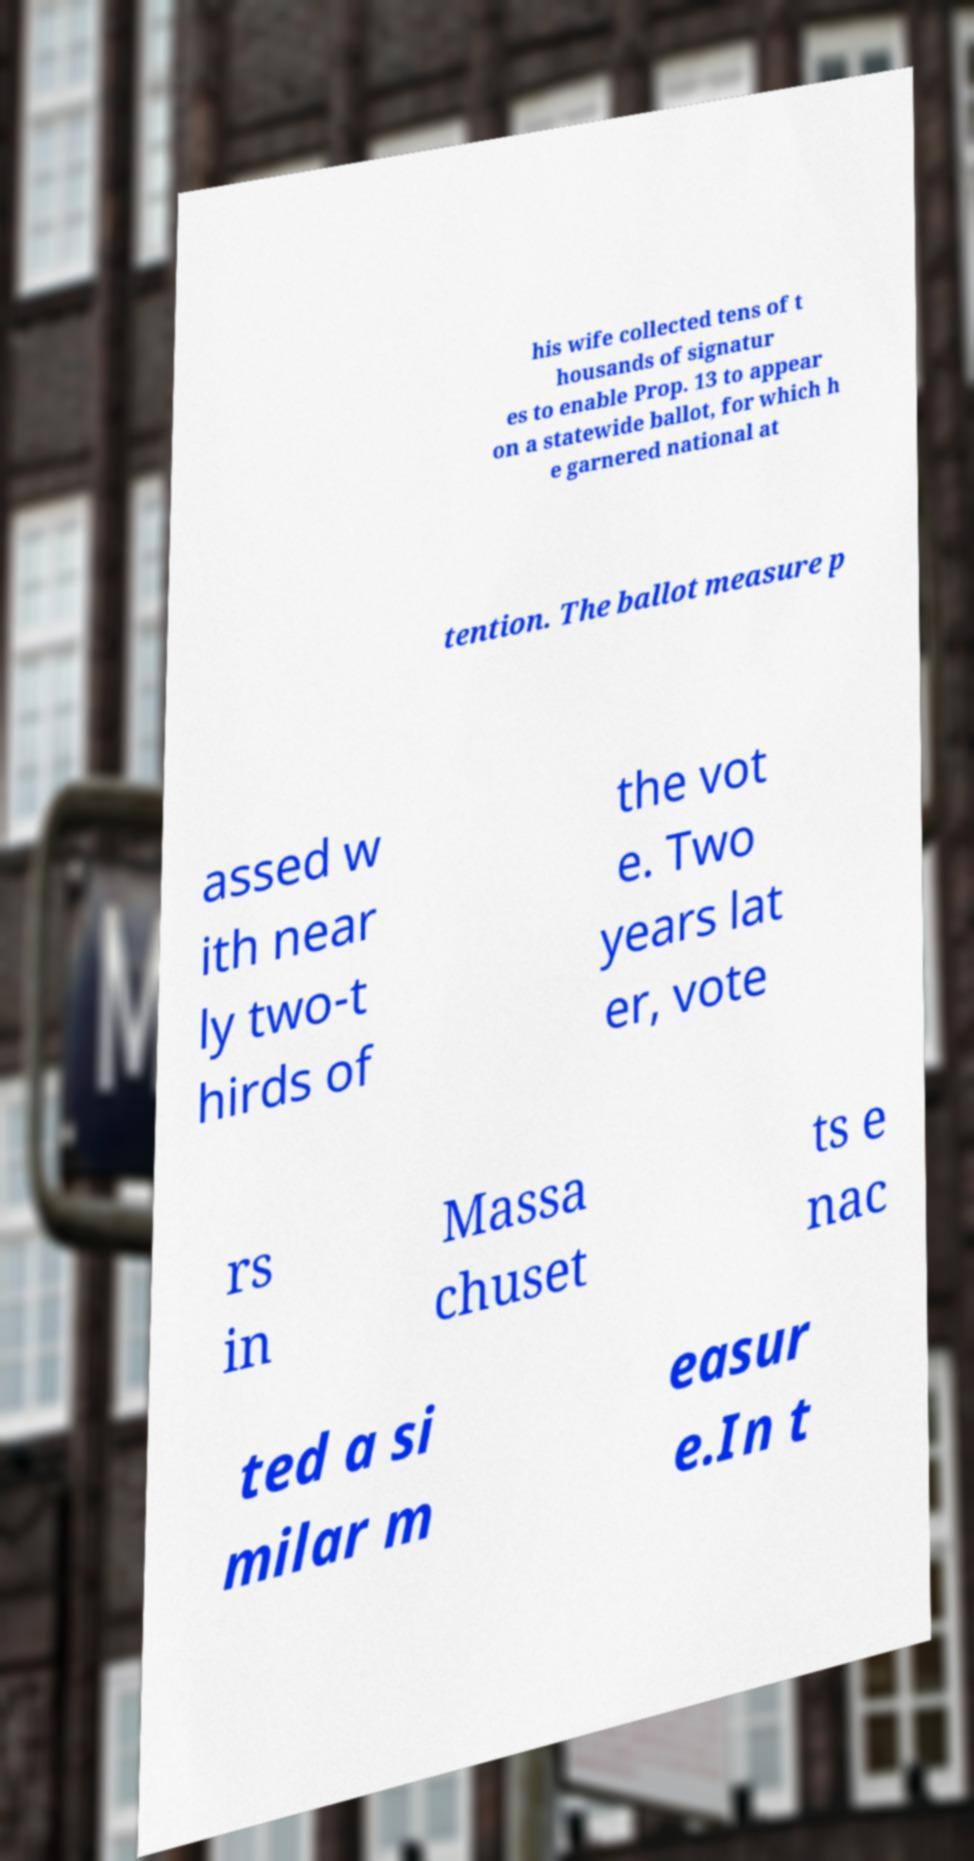For documentation purposes, I need the text within this image transcribed. Could you provide that? his wife collected tens of t housands of signatur es to enable Prop. 13 to appear on a statewide ballot, for which h e garnered national at tention. The ballot measure p assed w ith near ly two-t hirds of the vot e. Two years lat er, vote rs in Massa chuset ts e nac ted a si milar m easur e.In t 